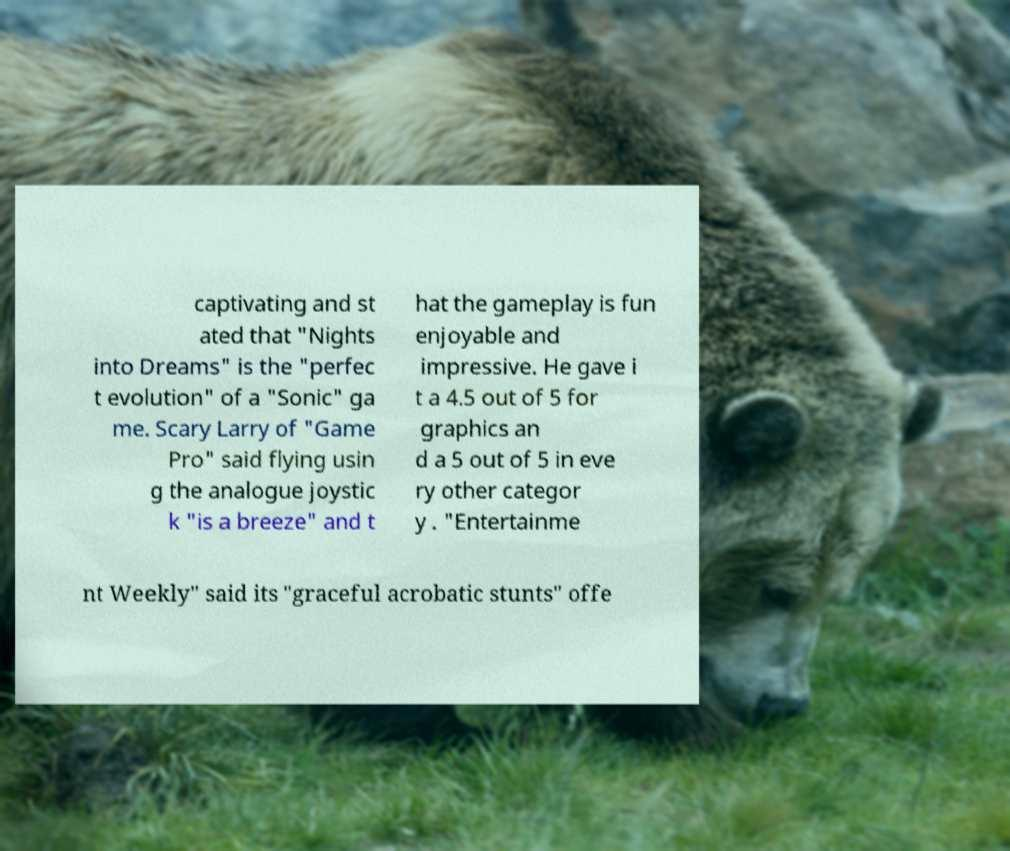Could you assist in decoding the text presented in this image and type it out clearly? captivating and st ated that "Nights into Dreams" is the "perfec t evolution" of a "Sonic" ga me. Scary Larry of "Game Pro" said flying usin g the analogue joystic k "is a breeze" and t hat the gameplay is fun enjoyable and impressive. He gave i t a 4.5 out of 5 for graphics an d a 5 out of 5 in eve ry other categor y . "Entertainme nt Weekly" said its "graceful acrobatic stunts" offe 